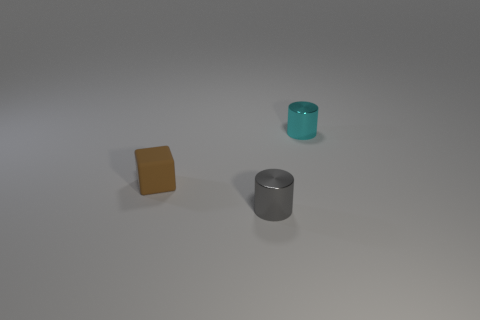Can you describe the shapes and colors of the objects in the image? Certainly! There are three objects in the image: a mustard-colored matte cube, a teal cylindrical container with a reflective surface, and a metallic grey cylinder with a matte finish. 